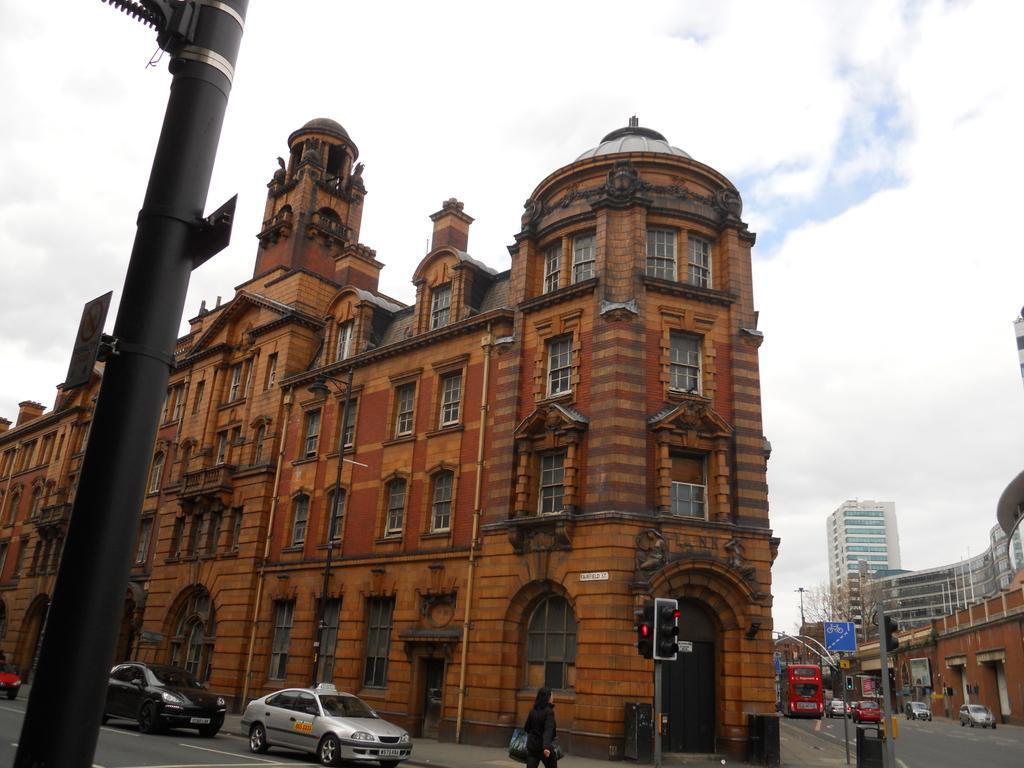Can you describe this image briefly? In this picture we can see buildings, poles, boards, traffic signals, bins, and a person. There are vehicles on the road. In the background there is sky with clouds. 